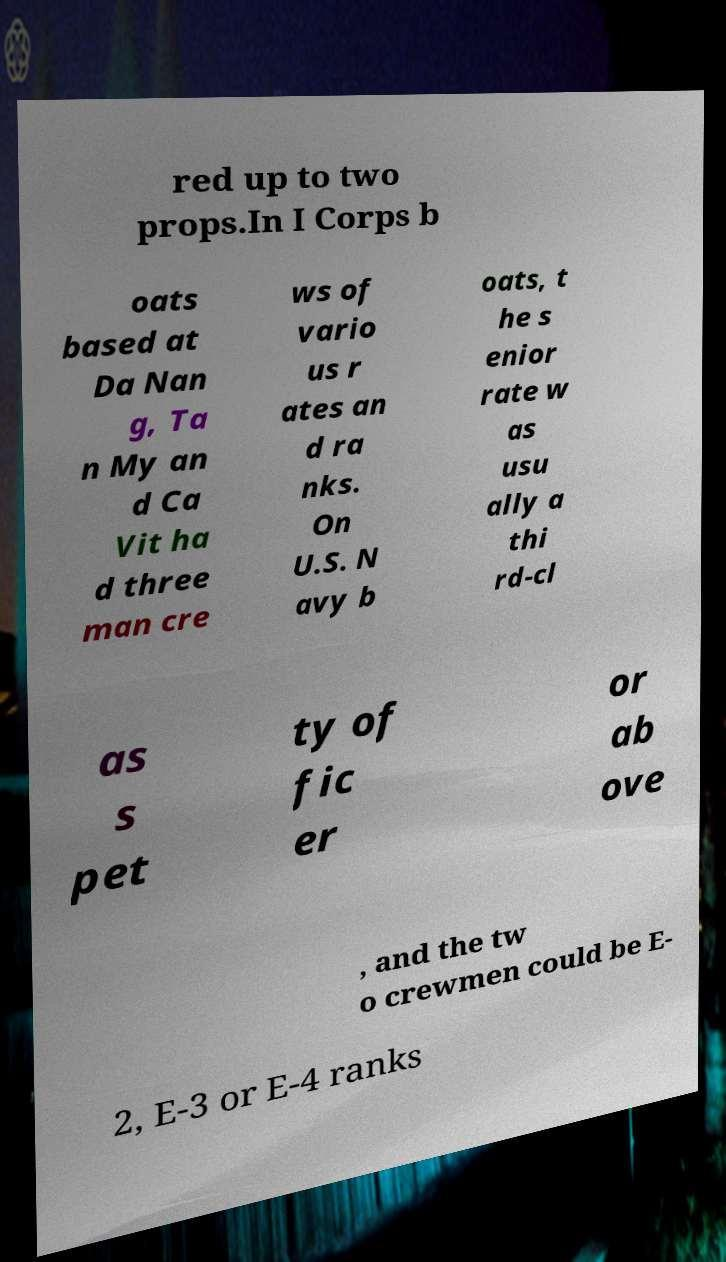What messages or text are displayed in this image? I need them in a readable, typed format. red up to two props.In I Corps b oats based at Da Nan g, Ta n My an d Ca Vit ha d three man cre ws of vario us r ates an d ra nks. On U.S. N avy b oats, t he s enior rate w as usu ally a thi rd-cl as s pet ty of fic er or ab ove , and the tw o crewmen could be E- 2, E-3 or E-4 ranks 